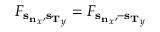<formula> <loc_0><loc_0><loc_500><loc_500>F _ { { s _ { n } } _ { x } , { s _ { T } } _ { y } } = F _ { { s _ { n } } _ { x } , { - s _ { T } } _ { y } }</formula> 